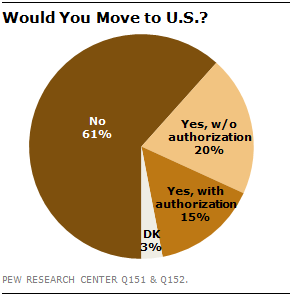List a handful of essential elements in this visual. Of the respondents surveyed, 61% stated that they would not move to the United States. The ratio of the two smallest segments is 1:5. Yes, that is correct. 